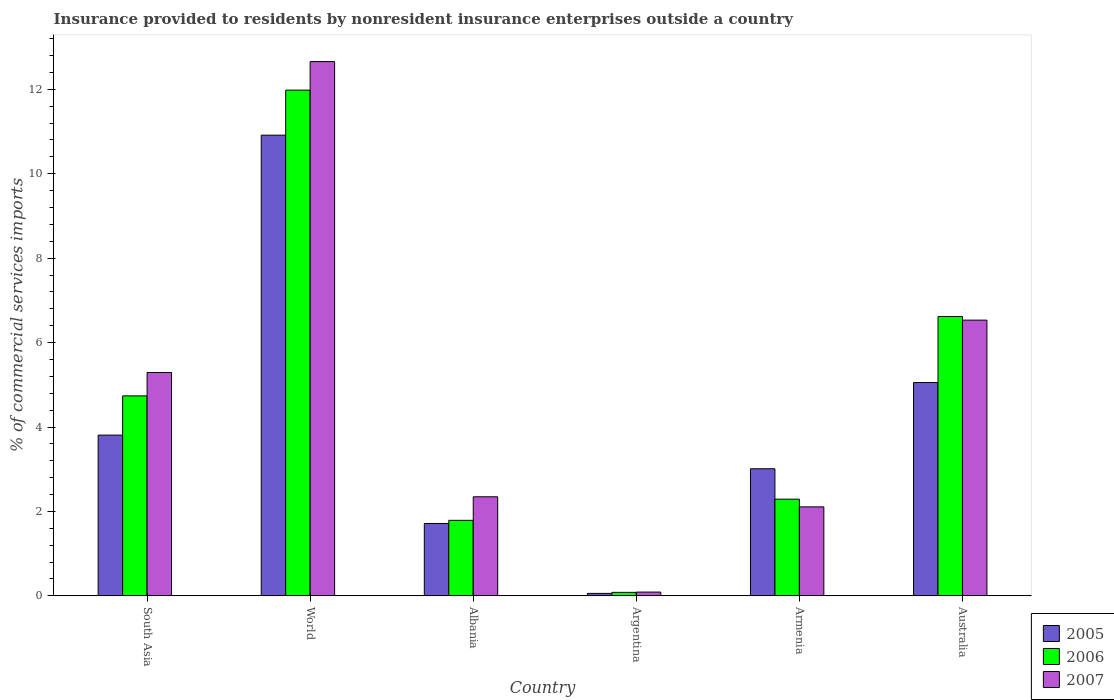How many different coloured bars are there?
Provide a succinct answer. 3. Are the number of bars on each tick of the X-axis equal?
Offer a very short reply. Yes. How many bars are there on the 3rd tick from the left?
Keep it short and to the point. 3. How many bars are there on the 4th tick from the right?
Make the answer very short. 3. What is the label of the 1st group of bars from the left?
Offer a terse response. South Asia. In how many cases, is the number of bars for a given country not equal to the number of legend labels?
Keep it short and to the point. 0. What is the Insurance provided to residents in 2007 in Argentina?
Keep it short and to the point. 0.09. Across all countries, what is the maximum Insurance provided to residents in 2005?
Offer a very short reply. 10.91. Across all countries, what is the minimum Insurance provided to residents in 2007?
Provide a short and direct response. 0.09. In which country was the Insurance provided to residents in 2007 maximum?
Your response must be concise. World. In which country was the Insurance provided to residents in 2007 minimum?
Your answer should be very brief. Argentina. What is the total Insurance provided to residents in 2006 in the graph?
Offer a terse response. 27.5. What is the difference between the Insurance provided to residents in 2007 in South Asia and that in World?
Offer a terse response. -7.37. What is the difference between the Insurance provided to residents in 2007 in Albania and the Insurance provided to residents in 2005 in South Asia?
Offer a very short reply. -1.46. What is the average Insurance provided to residents in 2005 per country?
Offer a very short reply. 4.09. What is the difference between the Insurance provided to residents of/in 2007 and Insurance provided to residents of/in 2006 in World?
Make the answer very short. 0.68. In how many countries, is the Insurance provided to residents in 2006 greater than 5.6 %?
Make the answer very short. 2. What is the ratio of the Insurance provided to residents in 2006 in Argentina to that in South Asia?
Your answer should be very brief. 0.02. Is the difference between the Insurance provided to residents in 2007 in Albania and World greater than the difference between the Insurance provided to residents in 2006 in Albania and World?
Provide a short and direct response. No. What is the difference between the highest and the second highest Insurance provided to residents in 2005?
Provide a short and direct response. 7.11. What is the difference between the highest and the lowest Insurance provided to residents in 2006?
Your answer should be compact. 11.9. Is the sum of the Insurance provided to residents in 2005 in Argentina and Australia greater than the maximum Insurance provided to residents in 2007 across all countries?
Provide a succinct answer. No. How many bars are there?
Give a very brief answer. 18. What is the difference between two consecutive major ticks on the Y-axis?
Your answer should be compact. 2. Are the values on the major ticks of Y-axis written in scientific E-notation?
Offer a very short reply. No. Does the graph contain any zero values?
Ensure brevity in your answer.  No. What is the title of the graph?
Provide a short and direct response. Insurance provided to residents by nonresident insurance enterprises outside a country. Does "1962" appear as one of the legend labels in the graph?
Ensure brevity in your answer.  No. What is the label or title of the X-axis?
Your answer should be compact. Country. What is the label or title of the Y-axis?
Provide a short and direct response. % of commercial services imports. What is the % of commercial services imports of 2005 in South Asia?
Make the answer very short. 3.81. What is the % of commercial services imports of 2006 in South Asia?
Offer a terse response. 4.74. What is the % of commercial services imports of 2007 in South Asia?
Keep it short and to the point. 5.29. What is the % of commercial services imports in 2005 in World?
Offer a very short reply. 10.91. What is the % of commercial services imports in 2006 in World?
Provide a short and direct response. 11.98. What is the % of commercial services imports in 2007 in World?
Your response must be concise. 12.66. What is the % of commercial services imports in 2005 in Albania?
Make the answer very short. 1.71. What is the % of commercial services imports in 2006 in Albania?
Give a very brief answer. 1.79. What is the % of commercial services imports in 2007 in Albania?
Ensure brevity in your answer.  2.35. What is the % of commercial services imports in 2005 in Argentina?
Keep it short and to the point. 0.06. What is the % of commercial services imports in 2006 in Argentina?
Provide a short and direct response. 0.08. What is the % of commercial services imports in 2007 in Argentina?
Keep it short and to the point. 0.09. What is the % of commercial services imports of 2005 in Armenia?
Your response must be concise. 3.01. What is the % of commercial services imports of 2006 in Armenia?
Your response must be concise. 2.29. What is the % of commercial services imports in 2007 in Armenia?
Keep it short and to the point. 2.11. What is the % of commercial services imports in 2005 in Australia?
Provide a succinct answer. 5.05. What is the % of commercial services imports of 2006 in Australia?
Offer a very short reply. 6.62. What is the % of commercial services imports of 2007 in Australia?
Make the answer very short. 6.53. Across all countries, what is the maximum % of commercial services imports in 2005?
Offer a terse response. 10.91. Across all countries, what is the maximum % of commercial services imports of 2006?
Your response must be concise. 11.98. Across all countries, what is the maximum % of commercial services imports of 2007?
Offer a terse response. 12.66. Across all countries, what is the minimum % of commercial services imports in 2005?
Make the answer very short. 0.06. Across all countries, what is the minimum % of commercial services imports in 2006?
Give a very brief answer. 0.08. Across all countries, what is the minimum % of commercial services imports in 2007?
Ensure brevity in your answer.  0.09. What is the total % of commercial services imports of 2005 in the graph?
Provide a succinct answer. 24.56. What is the total % of commercial services imports of 2006 in the graph?
Keep it short and to the point. 27.5. What is the total % of commercial services imports in 2007 in the graph?
Offer a terse response. 29.02. What is the difference between the % of commercial services imports of 2005 in South Asia and that in World?
Offer a very short reply. -7.11. What is the difference between the % of commercial services imports of 2006 in South Asia and that in World?
Offer a terse response. -7.24. What is the difference between the % of commercial services imports in 2007 in South Asia and that in World?
Provide a succinct answer. -7.37. What is the difference between the % of commercial services imports of 2005 in South Asia and that in Albania?
Make the answer very short. 2.09. What is the difference between the % of commercial services imports in 2006 in South Asia and that in Albania?
Your answer should be compact. 2.95. What is the difference between the % of commercial services imports in 2007 in South Asia and that in Albania?
Your answer should be very brief. 2.94. What is the difference between the % of commercial services imports of 2005 in South Asia and that in Argentina?
Provide a succinct answer. 3.75. What is the difference between the % of commercial services imports of 2006 in South Asia and that in Argentina?
Provide a short and direct response. 4.66. What is the difference between the % of commercial services imports in 2007 in South Asia and that in Argentina?
Your response must be concise. 5.2. What is the difference between the % of commercial services imports in 2005 in South Asia and that in Armenia?
Make the answer very short. 0.8. What is the difference between the % of commercial services imports of 2006 in South Asia and that in Armenia?
Your answer should be compact. 2.45. What is the difference between the % of commercial services imports of 2007 in South Asia and that in Armenia?
Provide a succinct answer. 3.18. What is the difference between the % of commercial services imports of 2005 in South Asia and that in Australia?
Your answer should be compact. -1.25. What is the difference between the % of commercial services imports of 2006 in South Asia and that in Australia?
Offer a terse response. -1.88. What is the difference between the % of commercial services imports of 2007 in South Asia and that in Australia?
Ensure brevity in your answer.  -1.24. What is the difference between the % of commercial services imports of 2005 in World and that in Albania?
Keep it short and to the point. 9.2. What is the difference between the % of commercial services imports of 2006 in World and that in Albania?
Keep it short and to the point. 10.19. What is the difference between the % of commercial services imports in 2007 in World and that in Albania?
Your answer should be very brief. 10.31. What is the difference between the % of commercial services imports of 2005 in World and that in Argentina?
Your answer should be compact. 10.86. What is the difference between the % of commercial services imports in 2006 in World and that in Argentina?
Your response must be concise. 11.9. What is the difference between the % of commercial services imports of 2007 in World and that in Argentina?
Keep it short and to the point. 12.57. What is the difference between the % of commercial services imports of 2005 in World and that in Armenia?
Provide a succinct answer. 7.9. What is the difference between the % of commercial services imports of 2006 in World and that in Armenia?
Your response must be concise. 9.69. What is the difference between the % of commercial services imports in 2007 in World and that in Armenia?
Keep it short and to the point. 10.55. What is the difference between the % of commercial services imports in 2005 in World and that in Australia?
Provide a succinct answer. 5.86. What is the difference between the % of commercial services imports of 2006 in World and that in Australia?
Your answer should be compact. 5.36. What is the difference between the % of commercial services imports in 2007 in World and that in Australia?
Your answer should be compact. 6.13. What is the difference between the % of commercial services imports of 2005 in Albania and that in Argentina?
Your answer should be compact. 1.66. What is the difference between the % of commercial services imports in 2006 in Albania and that in Argentina?
Provide a short and direct response. 1.71. What is the difference between the % of commercial services imports of 2007 in Albania and that in Argentina?
Your answer should be very brief. 2.26. What is the difference between the % of commercial services imports in 2005 in Albania and that in Armenia?
Your answer should be compact. -1.3. What is the difference between the % of commercial services imports in 2006 in Albania and that in Armenia?
Your response must be concise. -0.5. What is the difference between the % of commercial services imports in 2007 in Albania and that in Armenia?
Give a very brief answer. 0.24. What is the difference between the % of commercial services imports of 2005 in Albania and that in Australia?
Offer a very short reply. -3.34. What is the difference between the % of commercial services imports of 2006 in Albania and that in Australia?
Offer a terse response. -4.83. What is the difference between the % of commercial services imports in 2007 in Albania and that in Australia?
Provide a short and direct response. -4.19. What is the difference between the % of commercial services imports of 2005 in Argentina and that in Armenia?
Provide a succinct answer. -2.95. What is the difference between the % of commercial services imports in 2006 in Argentina and that in Armenia?
Keep it short and to the point. -2.21. What is the difference between the % of commercial services imports in 2007 in Argentina and that in Armenia?
Offer a terse response. -2.02. What is the difference between the % of commercial services imports in 2005 in Argentina and that in Australia?
Your response must be concise. -5. What is the difference between the % of commercial services imports of 2006 in Argentina and that in Australia?
Make the answer very short. -6.54. What is the difference between the % of commercial services imports in 2007 in Argentina and that in Australia?
Give a very brief answer. -6.44. What is the difference between the % of commercial services imports in 2005 in Armenia and that in Australia?
Your answer should be very brief. -2.04. What is the difference between the % of commercial services imports in 2006 in Armenia and that in Australia?
Keep it short and to the point. -4.33. What is the difference between the % of commercial services imports of 2007 in Armenia and that in Australia?
Make the answer very short. -4.42. What is the difference between the % of commercial services imports of 2005 in South Asia and the % of commercial services imports of 2006 in World?
Your answer should be compact. -8.17. What is the difference between the % of commercial services imports in 2005 in South Asia and the % of commercial services imports in 2007 in World?
Your answer should be very brief. -8.85. What is the difference between the % of commercial services imports of 2006 in South Asia and the % of commercial services imports of 2007 in World?
Give a very brief answer. -7.92. What is the difference between the % of commercial services imports of 2005 in South Asia and the % of commercial services imports of 2006 in Albania?
Provide a short and direct response. 2.02. What is the difference between the % of commercial services imports in 2005 in South Asia and the % of commercial services imports in 2007 in Albania?
Your answer should be compact. 1.46. What is the difference between the % of commercial services imports of 2006 in South Asia and the % of commercial services imports of 2007 in Albania?
Your answer should be very brief. 2.39. What is the difference between the % of commercial services imports in 2005 in South Asia and the % of commercial services imports in 2006 in Argentina?
Offer a very short reply. 3.73. What is the difference between the % of commercial services imports of 2005 in South Asia and the % of commercial services imports of 2007 in Argentina?
Your answer should be compact. 3.72. What is the difference between the % of commercial services imports of 2006 in South Asia and the % of commercial services imports of 2007 in Argentina?
Offer a very short reply. 4.65. What is the difference between the % of commercial services imports in 2005 in South Asia and the % of commercial services imports in 2006 in Armenia?
Ensure brevity in your answer.  1.52. What is the difference between the % of commercial services imports of 2005 in South Asia and the % of commercial services imports of 2007 in Armenia?
Ensure brevity in your answer.  1.7. What is the difference between the % of commercial services imports of 2006 in South Asia and the % of commercial services imports of 2007 in Armenia?
Make the answer very short. 2.63. What is the difference between the % of commercial services imports of 2005 in South Asia and the % of commercial services imports of 2006 in Australia?
Your response must be concise. -2.81. What is the difference between the % of commercial services imports of 2005 in South Asia and the % of commercial services imports of 2007 in Australia?
Provide a short and direct response. -2.72. What is the difference between the % of commercial services imports in 2006 in South Asia and the % of commercial services imports in 2007 in Australia?
Make the answer very short. -1.79. What is the difference between the % of commercial services imports in 2005 in World and the % of commercial services imports in 2006 in Albania?
Your answer should be very brief. 9.13. What is the difference between the % of commercial services imports of 2005 in World and the % of commercial services imports of 2007 in Albania?
Provide a succinct answer. 8.57. What is the difference between the % of commercial services imports of 2006 in World and the % of commercial services imports of 2007 in Albania?
Offer a terse response. 9.63. What is the difference between the % of commercial services imports of 2005 in World and the % of commercial services imports of 2006 in Argentina?
Your answer should be compact. 10.83. What is the difference between the % of commercial services imports of 2005 in World and the % of commercial services imports of 2007 in Argentina?
Ensure brevity in your answer.  10.83. What is the difference between the % of commercial services imports of 2006 in World and the % of commercial services imports of 2007 in Argentina?
Your answer should be compact. 11.89. What is the difference between the % of commercial services imports of 2005 in World and the % of commercial services imports of 2006 in Armenia?
Give a very brief answer. 8.62. What is the difference between the % of commercial services imports in 2005 in World and the % of commercial services imports in 2007 in Armenia?
Your response must be concise. 8.81. What is the difference between the % of commercial services imports of 2006 in World and the % of commercial services imports of 2007 in Armenia?
Your answer should be very brief. 9.87. What is the difference between the % of commercial services imports in 2005 in World and the % of commercial services imports in 2006 in Australia?
Provide a short and direct response. 4.3. What is the difference between the % of commercial services imports of 2005 in World and the % of commercial services imports of 2007 in Australia?
Give a very brief answer. 4.38. What is the difference between the % of commercial services imports of 2006 in World and the % of commercial services imports of 2007 in Australia?
Provide a short and direct response. 5.45. What is the difference between the % of commercial services imports in 2005 in Albania and the % of commercial services imports in 2006 in Argentina?
Offer a very short reply. 1.63. What is the difference between the % of commercial services imports of 2005 in Albania and the % of commercial services imports of 2007 in Argentina?
Your answer should be very brief. 1.63. What is the difference between the % of commercial services imports of 2006 in Albania and the % of commercial services imports of 2007 in Argentina?
Keep it short and to the point. 1.7. What is the difference between the % of commercial services imports in 2005 in Albania and the % of commercial services imports in 2006 in Armenia?
Give a very brief answer. -0.58. What is the difference between the % of commercial services imports in 2005 in Albania and the % of commercial services imports in 2007 in Armenia?
Provide a short and direct response. -0.39. What is the difference between the % of commercial services imports in 2006 in Albania and the % of commercial services imports in 2007 in Armenia?
Make the answer very short. -0.32. What is the difference between the % of commercial services imports of 2005 in Albania and the % of commercial services imports of 2006 in Australia?
Give a very brief answer. -4.9. What is the difference between the % of commercial services imports of 2005 in Albania and the % of commercial services imports of 2007 in Australia?
Make the answer very short. -4.82. What is the difference between the % of commercial services imports in 2006 in Albania and the % of commercial services imports in 2007 in Australia?
Offer a terse response. -4.74. What is the difference between the % of commercial services imports in 2005 in Argentina and the % of commercial services imports in 2006 in Armenia?
Your response must be concise. -2.23. What is the difference between the % of commercial services imports of 2005 in Argentina and the % of commercial services imports of 2007 in Armenia?
Keep it short and to the point. -2.05. What is the difference between the % of commercial services imports in 2006 in Argentina and the % of commercial services imports in 2007 in Armenia?
Give a very brief answer. -2.03. What is the difference between the % of commercial services imports of 2005 in Argentina and the % of commercial services imports of 2006 in Australia?
Offer a terse response. -6.56. What is the difference between the % of commercial services imports of 2005 in Argentina and the % of commercial services imports of 2007 in Australia?
Offer a very short reply. -6.47. What is the difference between the % of commercial services imports of 2006 in Argentina and the % of commercial services imports of 2007 in Australia?
Keep it short and to the point. -6.45. What is the difference between the % of commercial services imports of 2005 in Armenia and the % of commercial services imports of 2006 in Australia?
Provide a succinct answer. -3.61. What is the difference between the % of commercial services imports in 2005 in Armenia and the % of commercial services imports in 2007 in Australia?
Provide a short and direct response. -3.52. What is the difference between the % of commercial services imports of 2006 in Armenia and the % of commercial services imports of 2007 in Australia?
Your answer should be compact. -4.24. What is the average % of commercial services imports of 2005 per country?
Give a very brief answer. 4.09. What is the average % of commercial services imports of 2006 per country?
Provide a succinct answer. 4.58. What is the average % of commercial services imports of 2007 per country?
Offer a terse response. 4.84. What is the difference between the % of commercial services imports of 2005 and % of commercial services imports of 2006 in South Asia?
Make the answer very short. -0.93. What is the difference between the % of commercial services imports in 2005 and % of commercial services imports in 2007 in South Asia?
Provide a succinct answer. -1.48. What is the difference between the % of commercial services imports of 2006 and % of commercial services imports of 2007 in South Asia?
Ensure brevity in your answer.  -0.55. What is the difference between the % of commercial services imports of 2005 and % of commercial services imports of 2006 in World?
Provide a short and direct response. -1.07. What is the difference between the % of commercial services imports of 2005 and % of commercial services imports of 2007 in World?
Make the answer very short. -1.74. What is the difference between the % of commercial services imports of 2006 and % of commercial services imports of 2007 in World?
Your answer should be compact. -0.68. What is the difference between the % of commercial services imports in 2005 and % of commercial services imports in 2006 in Albania?
Keep it short and to the point. -0.07. What is the difference between the % of commercial services imports in 2005 and % of commercial services imports in 2007 in Albania?
Give a very brief answer. -0.63. What is the difference between the % of commercial services imports of 2006 and % of commercial services imports of 2007 in Albania?
Your answer should be compact. -0.56. What is the difference between the % of commercial services imports of 2005 and % of commercial services imports of 2006 in Argentina?
Provide a succinct answer. -0.02. What is the difference between the % of commercial services imports in 2005 and % of commercial services imports in 2007 in Argentina?
Make the answer very short. -0.03. What is the difference between the % of commercial services imports of 2006 and % of commercial services imports of 2007 in Argentina?
Provide a succinct answer. -0.01. What is the difference between the % of commercial services imports in 2005 and % of commercial services imports in 2006 in Armenia?
Give a very brief answer. 0.72. What is the difference between the % of commercial services imports in 2005 and % of commercial services imports in 2007 in Armenia?
Your answer should be compact. 0.9. What is the difference between the % of commercial services imports in 2006 and % of commercial services imports in 2007 in Armenia?
Give a very brief answer. 0.18. What is the difference between the % of commercial services imports in 2005 and % of commercial services imports in 2006 in Australia?
Offer a terse response. -1.56. What is the difference between the % of commercial services imports of 2005 and % of commercial services imports of 2007 in Australia?
Your response must be concise. -1.48. What is the difference between the % of commercial services imports in 2006 and % of commercial services imports in 2007 in Australia?
Keep it short and to the point. 0.09. What is the ratio of the % of commercial services imports of 2005 in South Asia to that in World?
Give a very brief answer. 0.35. What is the ratio of the % of commercial services imports of 2006 in South Asia to that in World?
Give a very brief answer. 0.4. What is the ratio of the % of commercial services imports in 2007 in South Asia to that in World?
Your response must be concise. 0.42. What is the ratio of the % of commercial services imports of 2005 in South Asia to that in Albania?
Offer a terse response. 2.22. What is the ratio of the % of commercial services imports of 2006 in South Asia to that in Albania?
Give a very brief answer. 2.65. What is the ratio of the % of commercial services imports in 2007 in South Asia to that in Albania?
Give a very brief answer. 2.25. What is the ratio of the % of commercial services imports in 2005 in South Asia to that in Argentina?
Ensure brevity in your answer.  65.75. What is the ratio of the % of commercial services imports in 2006 in South Asia to that in Argentina?
Keep it short and to the point. 57.56. What is the ratio of the % of commercial services imports in 2007 in South Asia to that in Argentina?
Give a very brief answer. 59.4. What is the ratio of the % of commercial services imports of 2005 in South Asia to that in Armenia?
Your answer should be very brief. 1.26. What is the ratio of the % of commercial services imports of 2006 in South Asia to that in Armenia?
Give a very brief answer. 2.07. What is the ratio of the % of commercial services imports in 2007 in South Asia to that in Armenia?
Give a very brief answer. 2.51. What is the ratio of the % of commercial services imports in 2005 in South Asia to that in Australia?
Your answer should be compact. 0.75. What is the ratio of the % of commercial services imports of 2006 in South Asia to that in Australia?
Offer a terse response. 0.72. What is the ratio of the % of commercial services imports of 2007 in South Asia to that in Australia?
Provide a short and direct response. 0.81. What is the ratio of the % of commercial services imports in 2005 in World to that in Albania?
Your response must be concise. 6.37. What is the ratio of the % of commercial services imports of 2006 in World to that in Albania?
Your answer should be compact. 6.7. What is the ratio of the % of commercial services imports in 2007 in World to that in Albania?
Your answer should be very brief. 5.39. What is the ratio of the % of commercial services imports of 2005 in World to that in Argentina?
Your answer should be very brief. 188.47. What is the ratio of the % of commercial services imports in 2006 in World to that in Argentina?
Your response must be concise. 145.59. What is the ratio of the % of commercial services imports of 2007 in World to that in Argentina?
Keep it short and to the point. 142.09. What is the ratio of the % of commercial services imports of 2005 in World to that in Armenia?
Keep it short and to the point. 3.63. What is the ratio of the % of commercial services imports of 2006 in World to that in Armenia?
Provide a succinct answer. 5.23. What is the ratio of the % of commercial services imports of 2007 in World to that in Armenia?
Keep it short and to the point. 6.01. What is the ratio of the % of commercial services imports of 2005 in World to that in Australia?
Ensure brevity in your answer.  2.16. What is the ratio of the % of commercial services imports in 2006 in World to that in Australia?
Make the answer very short. 1.81. What is the ratio of the % of commercial services imports in 2007 in World to that in Australia?
Offer a very short reply. 1.94. What is the ratio of the % of commercial services imports of 2005 in Albania to that in Argentina?
Provide a short and direct response. 29.6. What is the ratio of the % of commercial services imports in 2006 in Albania to that in Argentina?
Provide a succinct answer. 21.74. What is the ratio of the % of commercial services imports of 2007 in Albania to that in Argentina?
Keep it short and to the point. 26.34. What is the ratio of the % of commercial services imports of 2005 in Albania to that in Armenia?
Ensure brevity in your answer.  0.57. What is the ratio of the % of commercial services imports in 2006 in Albania to that in Armenia?
Give a very brief answer. 0.78. What is the ratio of the % of commercial services imports of 2007 in Albania to that in Armenia?
Give a very brief answer. 1.11. What is the ratio of the % of commercial services imports of 2005 in Albania to that in Australia?
Provide a succinct answer. 0.34. What is the ratio of the % of commercial services imports of 2006 in Albania to that in Australia?
Give a very brief answer. 0.27. What is the ratio of the % of commercial services imports of 2007 in Albania to that in Australia?
Give a very brief answer. 0.36. What is the ratio of the % of commercial services imports in 2005 in Argentina to that in Armenia?
Provide a short and direct response. 0.02. What is the ratio of the % of commercial services imports of 2006 in Argentina to that in Armenia?
Offer a terse response. 0.04. What is the ratio of the % of commercial services imports in 2007 in Argentina to that in Armenia?
Your response must be concise. 0.04. What is the ratio of the % of commercial services imports of 2005 in Argentina to that in Australia?
Offer a terse response. 0.01. What is the ratio of the % of commercial services imports in 2006 in Argentina to that in Australia?
Offer a very short reply. 0.01. What is the ratio of the % of commercial services imports of 2007 in Argentina to that in Australia?
Give a very brief answer. 0.01. What is the ratio of the % of commercial services imports of 2005 in Armenia to that in Australia?
Your answer should be very brief. 0.6. What is the ratio of the % of commercial services imports of 2006 in Armenia to that in Australia?
Make the answer very short. 0.35. What is the ratio of the % of commercial services imports of 2007 in Armenia to that in Australia?
Give a very brief answer. 0.32. What is the difference between the highest and the second highest % of commercial services imports in 2005?
Your answer should be compact. 5.86. What is the difference between the highest and the second highest % of commercial services imports in 2006?
Ensure brevity in your answer.  5.36. What is the difference between the highest and the second highest % of commercial services imports of 2007?
Give a very brief answer. 6.13. What is the difference between the highest and the lowest % of commercial services imports in 2005?
Make the answer very short. 10.86. What is the difference between the highest and the lowest % of commercial services imports in 2006?
Provide a succinct answer. 11.9. What is the difference between the highest and the lowest % of commercial services imports of 2007?
Offer a terse response. 12.57. 